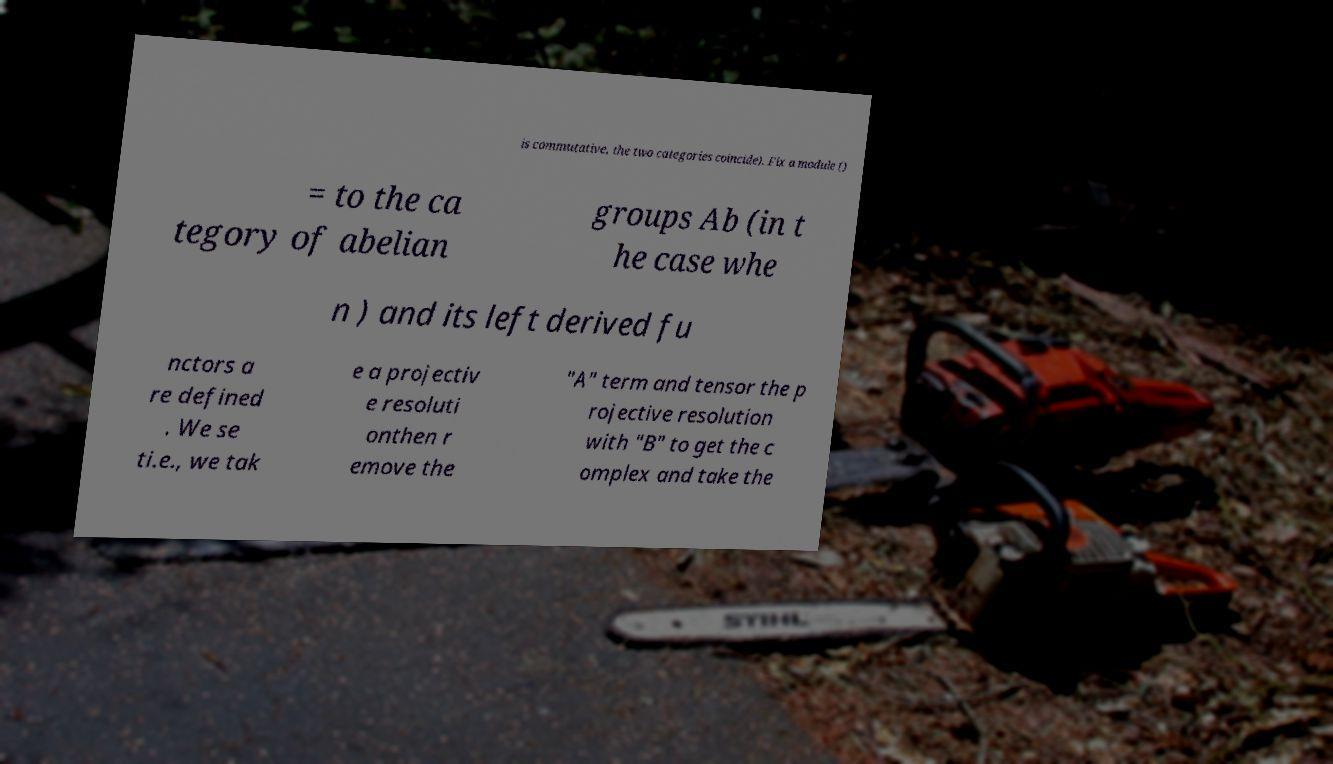There's text embedded in this image that I need extracted. Can you transcribe it verbatim? is commutative, the two categories coincide). Fix a module () = to the ca tegory of abelian groups Ab (in t he case whe n ) and its left derived fu nctors a re defined . We se ti.e., we tak e a projectiv e resoluti onthen r emove the "A" term and tensor the p rojective resolution with "B" to get the c omplex and take the 